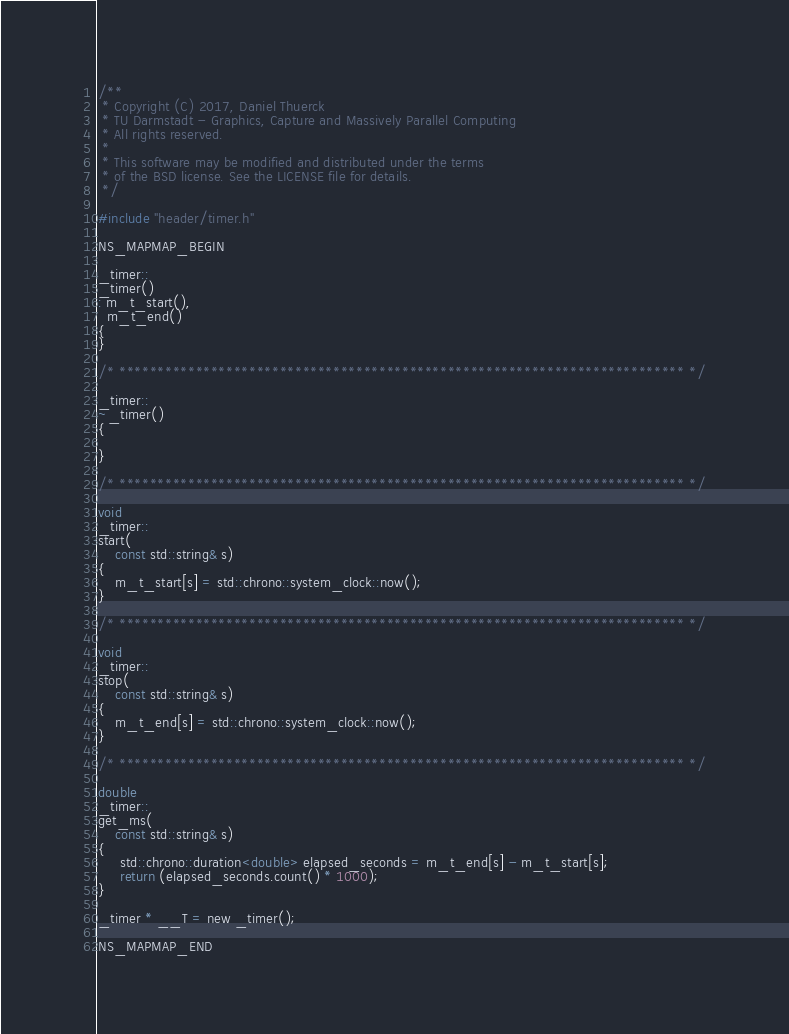Convert code to text. <code><loc_0><loc_0><loc_500><loc_500><_C_>/**
 * Copyright (C) 2017, Daniel Thuerck
 * TU Darmstadt - Graphics, Capture and Massively Parallel Computing
 * All rights reserved.
 *
 * This software may be modified and distributed under the terms
 * of the BSD license. See the LICENSE file for details.
 */

#include "header/timer.h"

NS_MAPMAP_BEGIN

_timer::
_timer()
: m_t_start(),
  m_t_end()
{
}

/* ************************************************************************** */

_timer::
~_timer()
{

}

/* ************************************************************************** */

void
_timer::
start(
    const std::string& s)
{
    m_t_start[s] = std::chrono::system_clock::now();
}

/* ************************************************************************** */

void
_timer::
stop(
    const std::string& s)
{
    m_t_end[s] = std::chrono::system_clock::now();
}

/* ************************************************************************** */

double
_timer::
get_ms(
    const std::string& s)
{
     std::chrono::duration<double> elapsed_seconds = m_t_end[s] - m_t_start[s];
     return (elapsed_seconds.count() * 1000);
}

_timer * __T = new _timer();

NS_MAPMAP_END</code> 